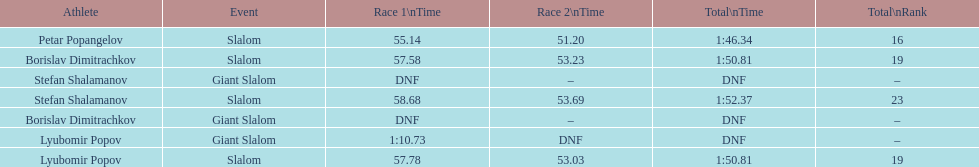Which athlete finished the first race but did not finish the second race? Lyubomir Popov. 